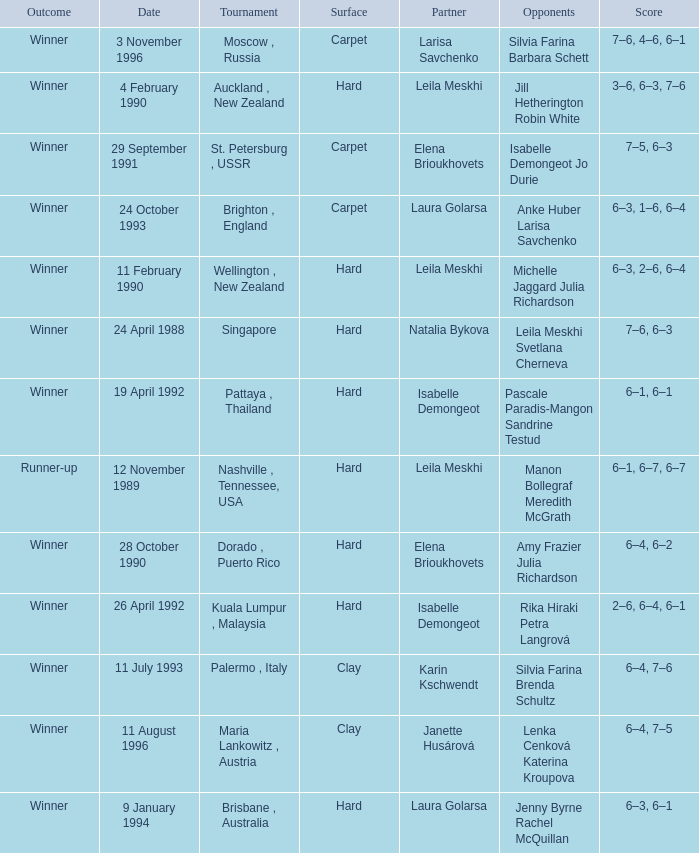Who was the Partner in a game with the Score of 6–4, 6–2 on a hard surface? Elena Brioukhovets. 